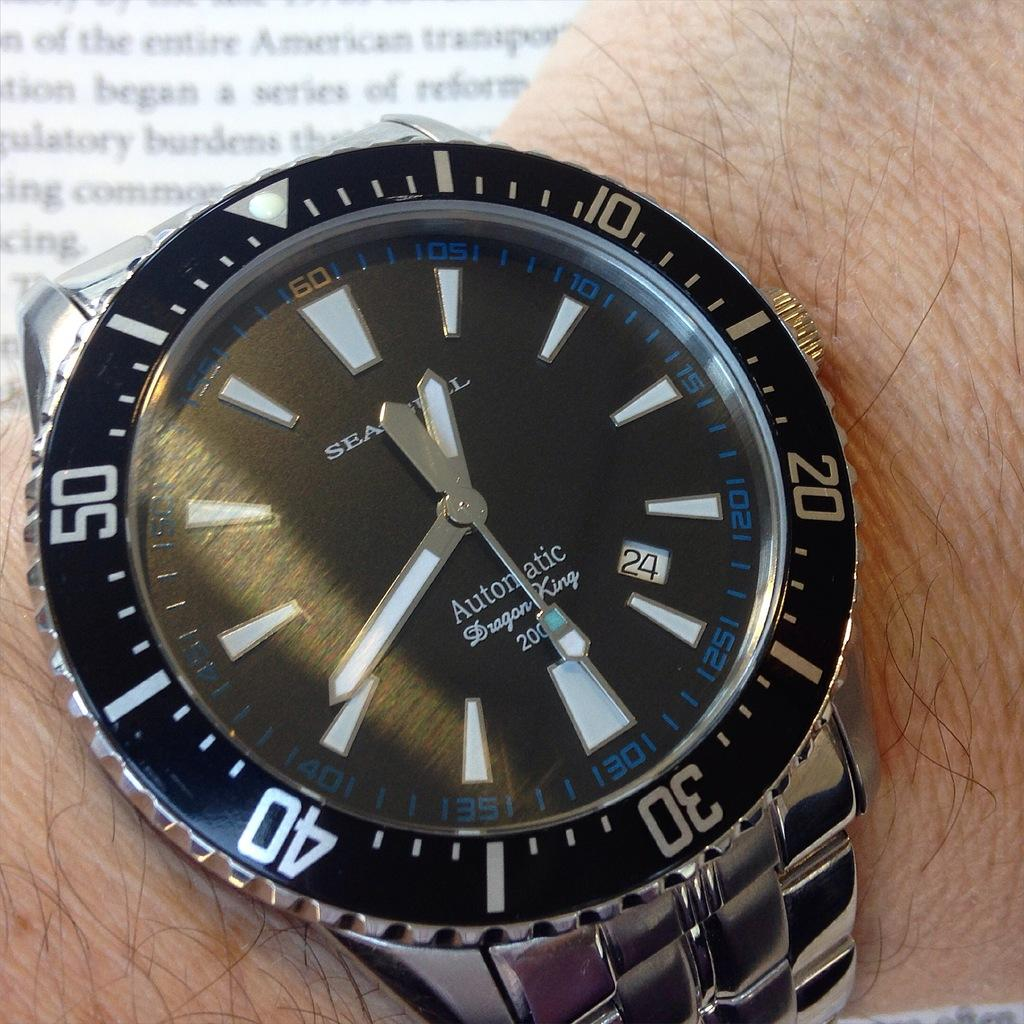Provide a one-sentence caption for the provided image. Inside the face of a watch shows the name Dragon King. 